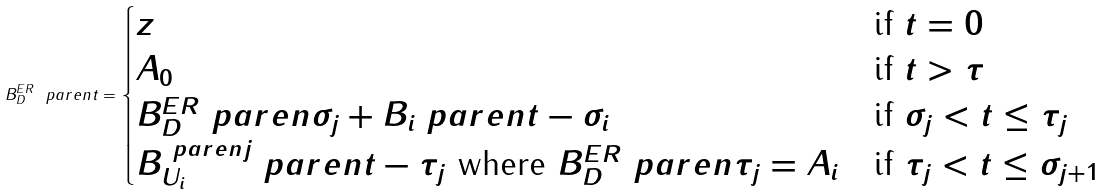<formula> <loc_0><loc_0><loc_500><loc_500>B ^ { E R } _ { D } \ p a r e n { t } = \begin{cases} z & \text {if } t = 0 \\ A _ { 0 } & \text {if } t > \tau \\ B ^ { E R } _ { D } \ p a r e n { \sigma _ { j } } + B _ { i } \ p a r e n { t - \sigma _ { i } } & \text {if } \sigma _ { j } < t \leq \tau _ { j } \\ B ^ { \ p a r e n { j } } _ { U _ { i } } \ p a r e n { t - \tau _ { j } } \text { where } B ^ { E R } _ { D } \ p a r e n { \tau _ { j } } = A _ { i } & \text {if } \tau _ { j } < t \leq \sigma _ { j + 1 } \end{cases}</formula> 